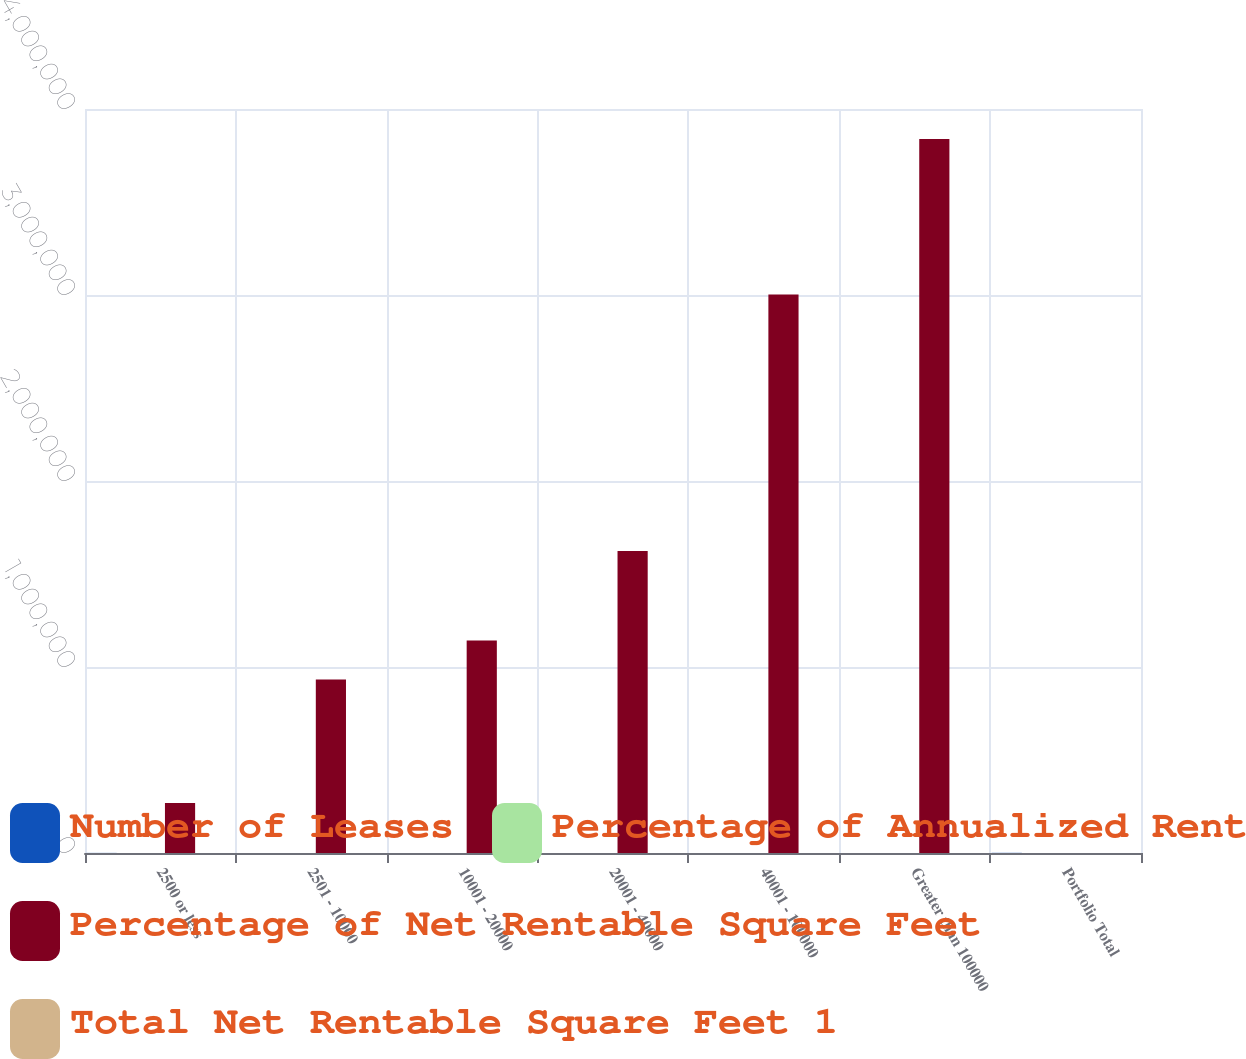Convert chart to OTSL. <chart><loc_0><loc_0><loc_500><loc_500><stacked_bar_chart><ecel><fcel>2500 or less<fcel>2501 - 10000<fcel>10001 - 20000<fcel>20001 - 40000<fcel>40001 - 100000<fcel>Greater than 100000<fcel>Portfolio Total<nl><fcel>Number of Leases<fcel>540<fcel>166<fcel>62<fcel>52<fcel>46<fcel>26<fcel>892<nl><fcel>Percentage of Annualized Rent<fcel>60.5<fcel>18.6<fcel>7<fcel>5.8<fcel>5.2<fcel>2.9<fcel>100<nl><fcel>Percentage of Net Rentable Square Feet<fcel>268922<fcel>933206<fcel>1.14261e+06<fcel>1.6236e+06<fcel>3.00262e+06<fcel>3.83867e+06<fcel>52<nl><fcel>Total Net Rentable Square Feet 1<fcel>2.4<fcel>8.2<fcel>10<fcel>14.2<fcel>26.4<fcel>33.7<fcel>100<nl></chart> 